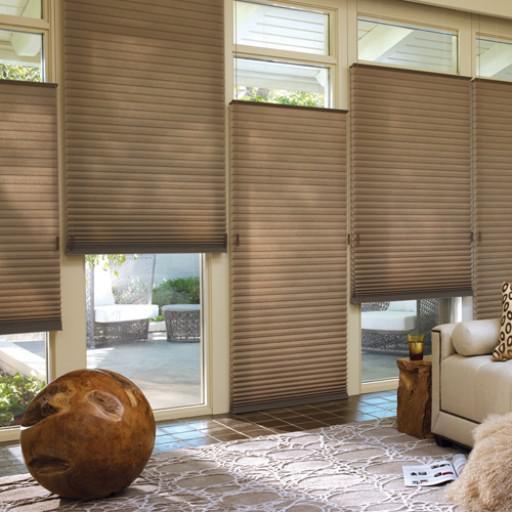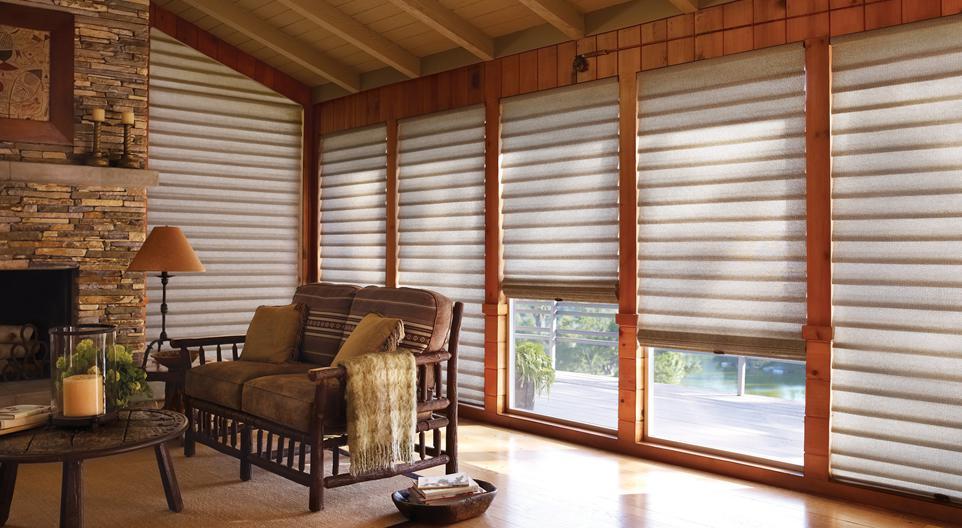The first image is the image on the left, the second image is the image on the right. Analyze the images presented: Is the assertion "Four sets of blinds are partially opened at the top of the window." valid? Answer yes or no. Yes. The first image is the image on the left, the second image is the image on the right. Evaluate the accuracy of this statement regarding the images: "There are at least ten window panes.". Is it true? Answer yes or no. Yes. 